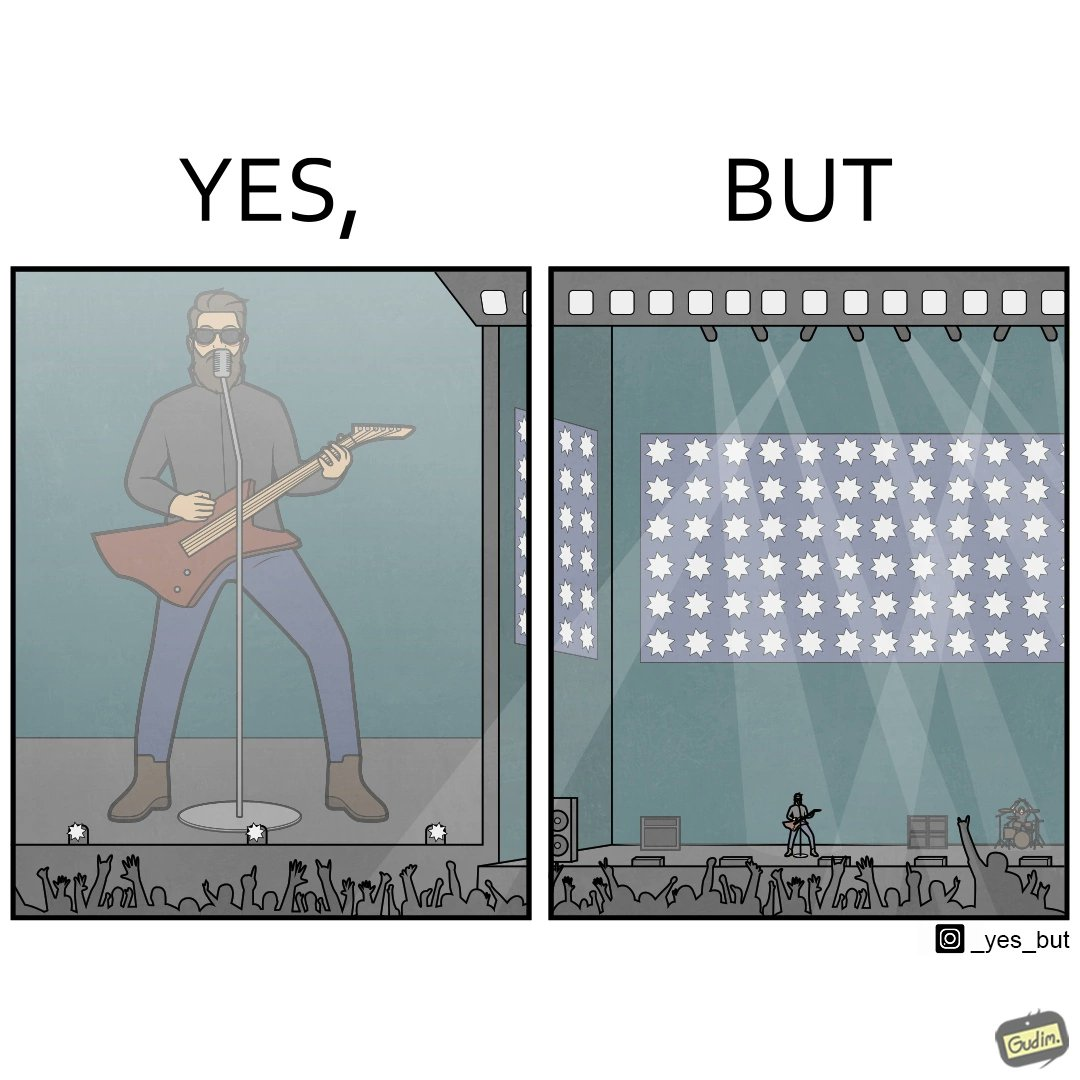Is this a satirical image? Yes, this image is satirical. 